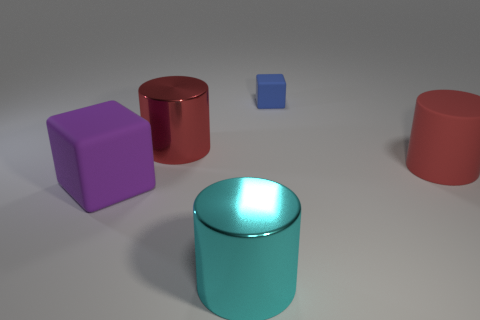Is there any other thing that has the same size as the blue rubber object?
Ensure brevity in your answer.  No. Are there the same number of large red things in front of the cyan cylinder and large rubber objects?
Ensure brevity in your answer.  No. Are there any shiny cylinders of the same color as the tiny block?
Ensure brevity in your answer.  No. Is the size of the blue block the same as the red metal thing?
Your response must be concise. No. How big is the blue block that is left of the large cylinder that is right of the large cyan object?
Your answer should be compact. Small. What size is the matte object that is both left of the red matte object and in front of the tiny matte cube?
Provide a succinct answer. Large. How many blue objects are the same size as the purple rubber block?
Your answer should be compact. 0. How many matte things are either large things or red objects?
Ensure brevity in your answer.  2. There is a thing that is the same color as the big rubber cylinder; what is its size?
Make the answer very short. Large. The big red thing in front of the metallic cylinder that is behind the big purple matte block is made of what material?
Give a very brief answer. Rubber. 